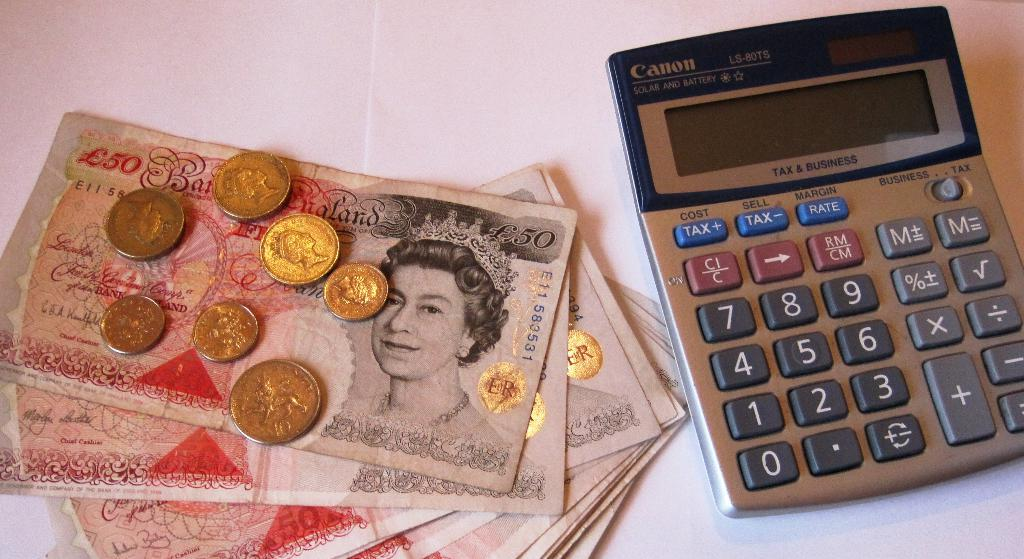Provide a one-sentence caption for the provided image. Foreign coins and bills sit next to a Canon calculator. 